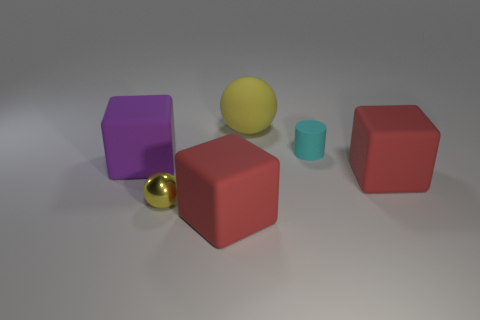Add 3 large yellow matte things. How many objects exist? 9 Subtract all spheres. How many objects are left? 4 Add 1 red matte balls. How many red matte balls exist? 1 Subtract 0 purple balls. How many objects are left? 6 Subtract all cyan things. Subtract all tiny brown blocks. How many objects are left? 5 Add 2 metal objects. How many metal objects are left? 3 